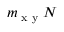Convert formula to latex. <formula><loc_0><loc_0><loc_500><loc_500>m _ { x y } N</formula> 